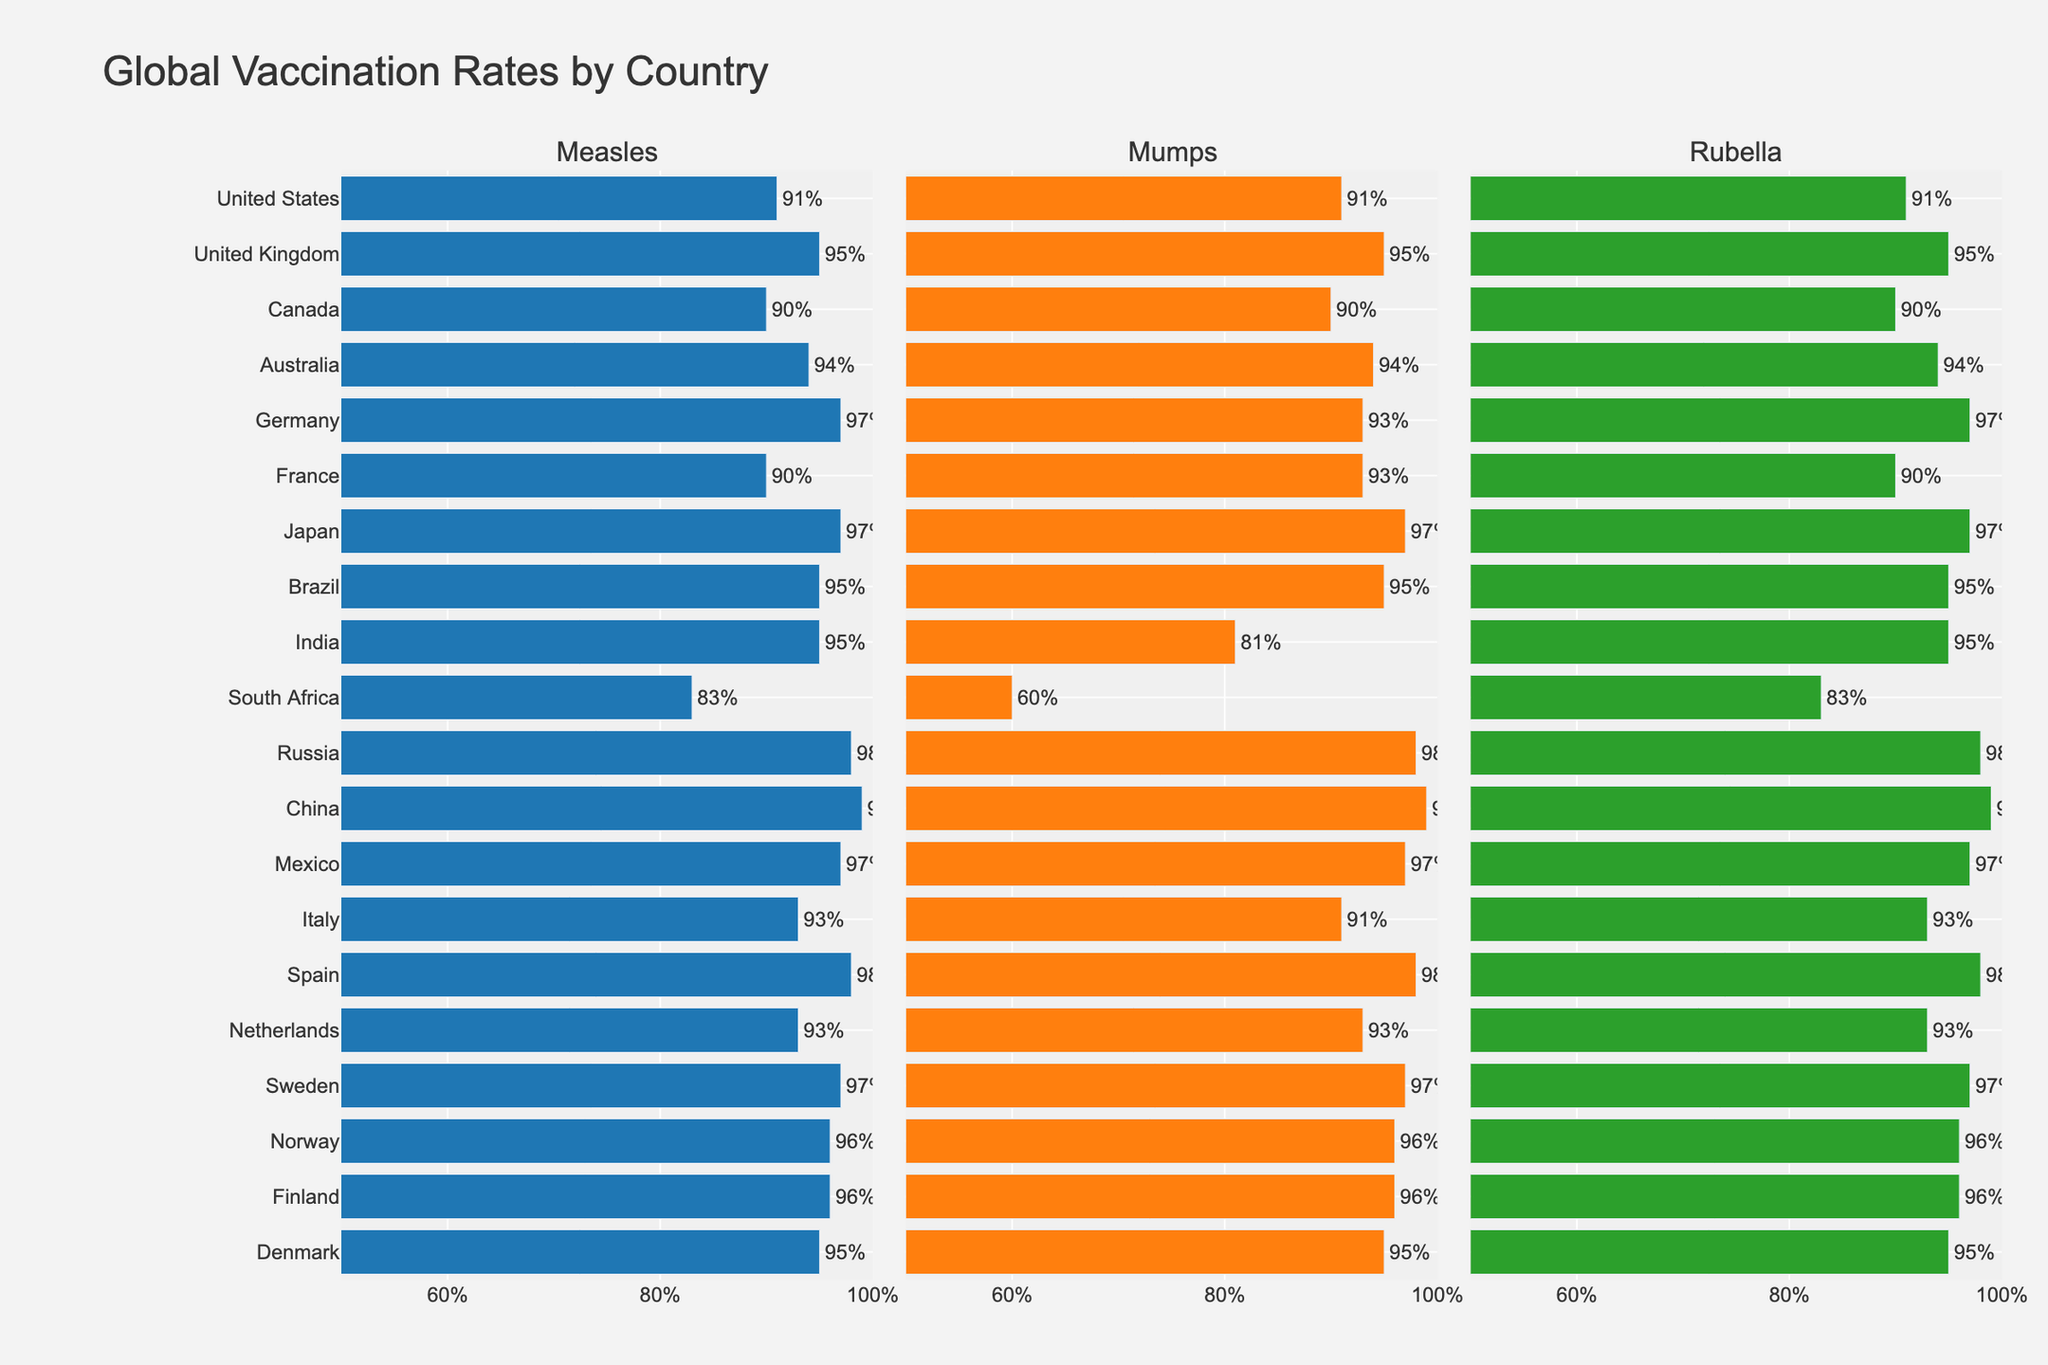What country has the highest vaccination rate for measles? By analyzing the three subplots, we notice that China has the highest value for measles vaccination at 99%.
Answer: China How does the vaccination rate for mumps in India compare to that in South Africa? By looking at the subplots for mumps, we see that India has a vaccination rate of 81%, whereas South Africa has a rate of 60%. So, India has a higher rate than South Africa for mumps.
Answer: India has a higher rate What is the average vaccination rate for rubella among the G7 countries (United States, United Kingdom, Canada, France, Germany, Italy, and Japan)? The G7 countries have the following rubella rates: United States (91%), United Kingdom (95%), Canada (90%), France (90%), Germany (97%), Italy (93%), Japan (97%). Sum these values and divide by 7: (91 + 95 + 90 + 90 + 97 + 93 + 97) / 7 = 93.29% (approx.).
Answer: 93.29% Which country has the most consistent vaccination rates across measles, mumps, and rubella? By comparing the bars for each country in the three subplots, Russia and China each have a consistent 98-99% rate for all three diseases. China has slightly higher overall rates.
Answer: China What is the difference in mumps vaccination rates between the country with the highest rate and the country with the lowest rate? Observing the mumps subplot, we see that China has the highest rate at 99% and South Africa has the lowest rate at 60%. The difference is 99% - 60% = 39%.
Answer: 39% Which countries have an equal vaccination rate for all three diseases? By visually inspecting the graphs, the countries with equal vaccination rates for measles, mumps, and rubella are United States, United Kingdom, Canada, Brazil, Mexico, and Sweden.
Answer: United States, United Kingdom, Canada, Brazil, Mexico, Sweden What is the range of measles vaccination rates among all countries? Looking at the measles subplot, the highest rate is in China with 99%, and the lowest is in South Africa with 83%. The range is 99% - 83% = 16%.
Answer: 16% How does the rubella vaccination rate in Germany compare to the rate in Canada? Observing the rubella subplot, Germany has a rate of 97%, while Canada has a rate of 90%. Germany's rate is higher.
Answer: Germany has a higher rate What is the total number of countries with measles vaccination rates of 95% or higher? From the measles subplot, count the number of countries with vaccination rates of 95% or higher: United Kingdom, Australia, Germany, Japan, Brazil, India, Russia, China, Mexico, Spain, Norway, Finland, Denmark. There are 13 such countries.
Answer: 13 Which countries have a mumps vaccination rate below 90%? Observing the mumps subplot, the countries with rates below 90% are India (81%) and South Africa (60%).
Answer: India, South Africa 